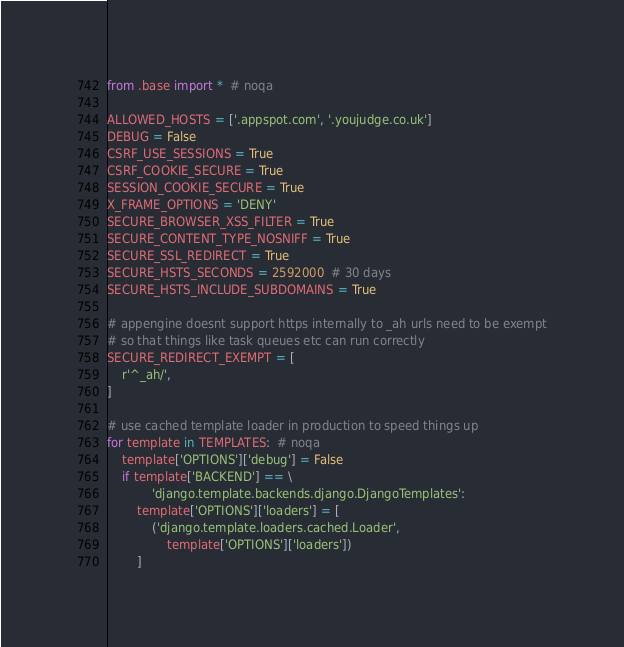<code> <loc_0><loc_0><loc_500><loc_500><_Python_>from .base import *  # noqa

ALLOWED_HOSTS = ['.appspot.com', '.youjudge.co.uk']
DEBUG = False
CSRF_USE_SESSIONS = True
CSRF_COOKIE_SECURE = True
SESSION_COOKIE_SECURE = True
X_FRAME_OPTIONS = 'DENY'
SECURE_BROWSER_XSS_FILTER = True
SECURE_CONTENT_TYPE_NOSNIFF = True
SECURE_SSL_REDIRECT = True
SECURE_HSTS_SECONDS = 2592000  # 30 days
SECURE_HSTS_INCLUDE_SUBDOMAINS = True

# appengine doesnt support https internally to _ah urls need to be exempt
# so that things like task queues etc can run correctly
SECURE_REDIRECT_EXEMPT = [
    r'^_ah/',
]

# use cached template loader in production to speed things up
for template in TEMPLATES:  # noqa
    template['OPTIONS']['debug'] = False
    if template['BACKEND'] == \
            'django.template.backends.django.DjangoTemplates':
        template['OPTIONS']['loaders'] = [
            ('django.template.loaders.cached.Loader',
                template['OPTIONS']['loaders'])
        ]
</code> 